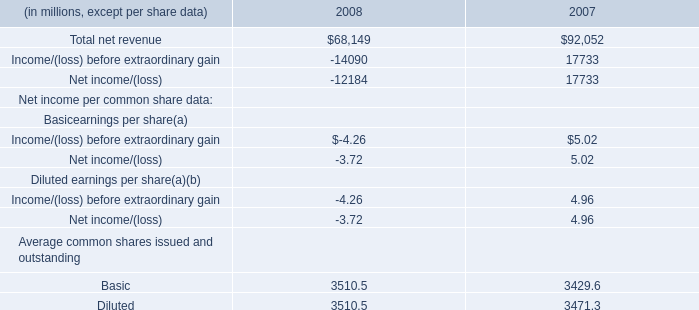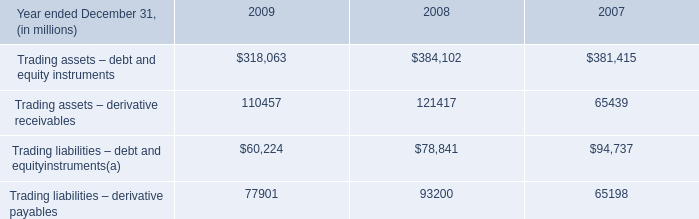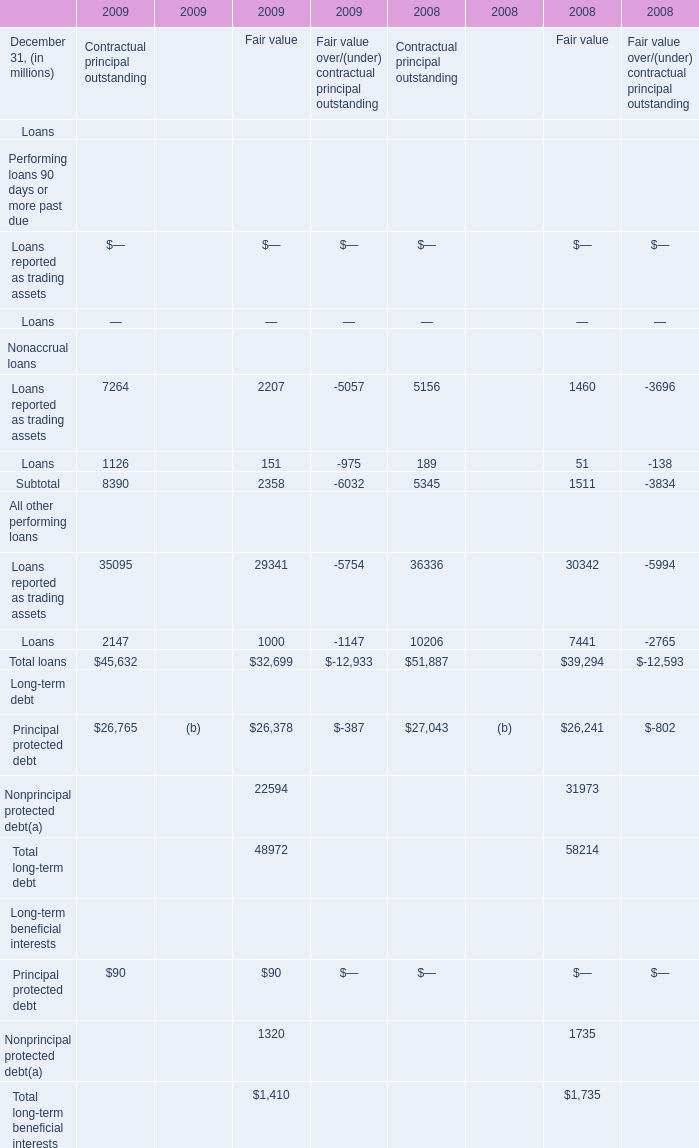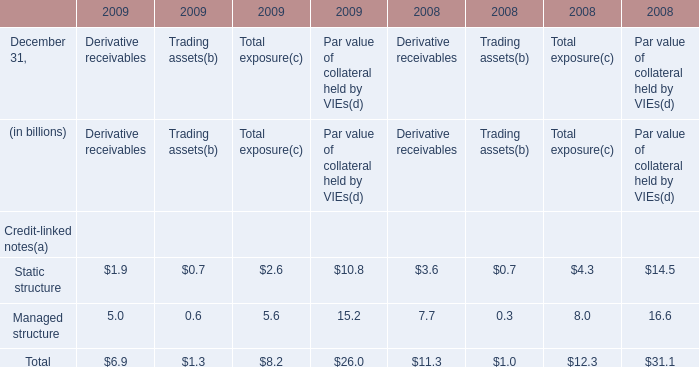what's the total amount of Trading liabilities – derivative payables of 2007, and Basic Average common shares issued and outstanding of 2007 ? 
Computations: (65198.0 + 3429.6)
Answer: 68627.6. 